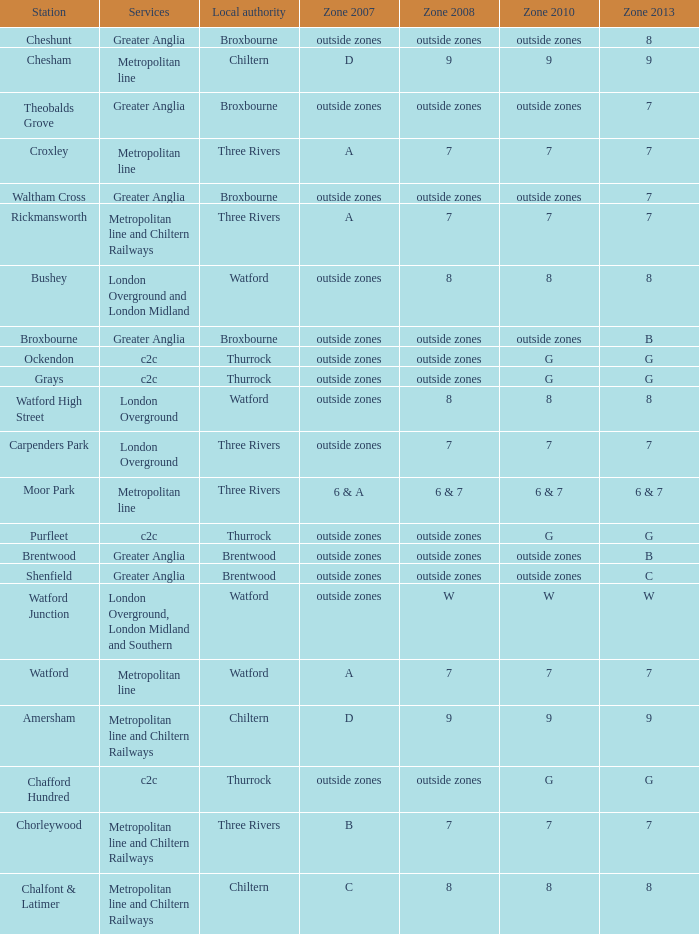Would you mind parsing the complete table? {'header': ['Station', 'Services', 'Local authority', 'Zone 2007', 'Zone 2008', 'Zone 2010', 'Zone 2013'], 'rows': [['Cheshunt', 'Greater Anglia', 'Broxbourne', 'outside zones', 'outside zones', 'outside zones', '8'], ['Chesham', 'Metropolitan line', 'Chiltern', 'D', '9', '9', '9'], ['Theobalds Grove', 'Greater Anglia', 'Broxbourne', 'outside zones', 'outside zones', 'outside zones', '7'], ['Croxley', 'Metropolitan line', 'Three Rivers', 'A', '7', '7', '7'], ['Waltham Cross', 'Greater Anglia', 'Broxbourne', 'outside zones', 'outside zones', 'outside zones', '7'], ['Rickmansworth', 'Metropolitan line and Chiltern Railways', 'Three Rivers', 'A', '7', '7', '7'], ['Bushey', 'London Overground and London Midland', 'Watford', 'outside zones', '8', '8', '8'], ['Broxbourne', 'Greater Anglia', 'Broxbourne', 'outside zones', 'outside zones', 'outside zones', 'B'], ['Ockendon', 'c2c', 'Thurrock', 'outside zones', 'outside zones', 'G', 'G'], ['Grays', 'c2c', 'Thurrock', 'outside zones', 'outside zones', 'G', 'G'], ['Watford High Street', 'London Overground', 'Watford', 'outside zones', '8', '8', '8'], ['Carpenders Park', 'London Overground', 'Three Rivers', 'outside zones', '7', '7', '7'], ['Moor Park', 'Metropolitan line', 'Three Rivers', '6 & A', '6 & 7', '6 & 7', '6 & 7'], ['Purfleet', 'c2c', 'Thurrock', 'outside zones', 'outside zones', 'G', 'G'], ['Brentwood', 'Greater Anglia', 'Brentwood', 'outside zones', 'outside zones', 'outside zones', 'B'], ['Shenfield', 'Greater Anglia', 'Brentwood', 'outside zones', 'outside zones', 'outside zones', 'C'], ['Watford Junction', 'London Overground, London Midland and Southern', 'Watford', 'outside zones', 'W', 'W', 'W'], ['Watford', 'Metropolitan line', 'Watford', 'A', '7', '7', '7'], ['Amersham', 'Metropolitan line and Chiltern Railways', 'Chiltern', 'D', '9', '9', '9'], ['Chafford Hundred', 'c2c', 'Thurrock', 'outside zones', 'outside zones', 'G', 'G'], ['Chorleywood', 'Metropolitan line and Chiltern Railways', 'Three Rivers', 'B', '7', '7', '7'], ['Chalfont & Latimer', 'Metropolitan line and Chiltern Railways', 'Chiltern', 'C', '8', '8', '8']]} Which Services have a Local authority of chiltern, and a Zone 2010 of 9? Metropolitan line and Chiltern Railways, Metropolitan line. 